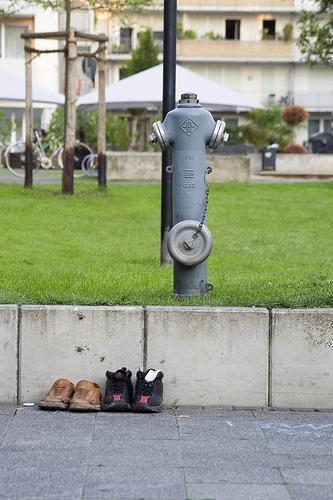How many fire hydrants are there?
Give a very brief answer. 1. 